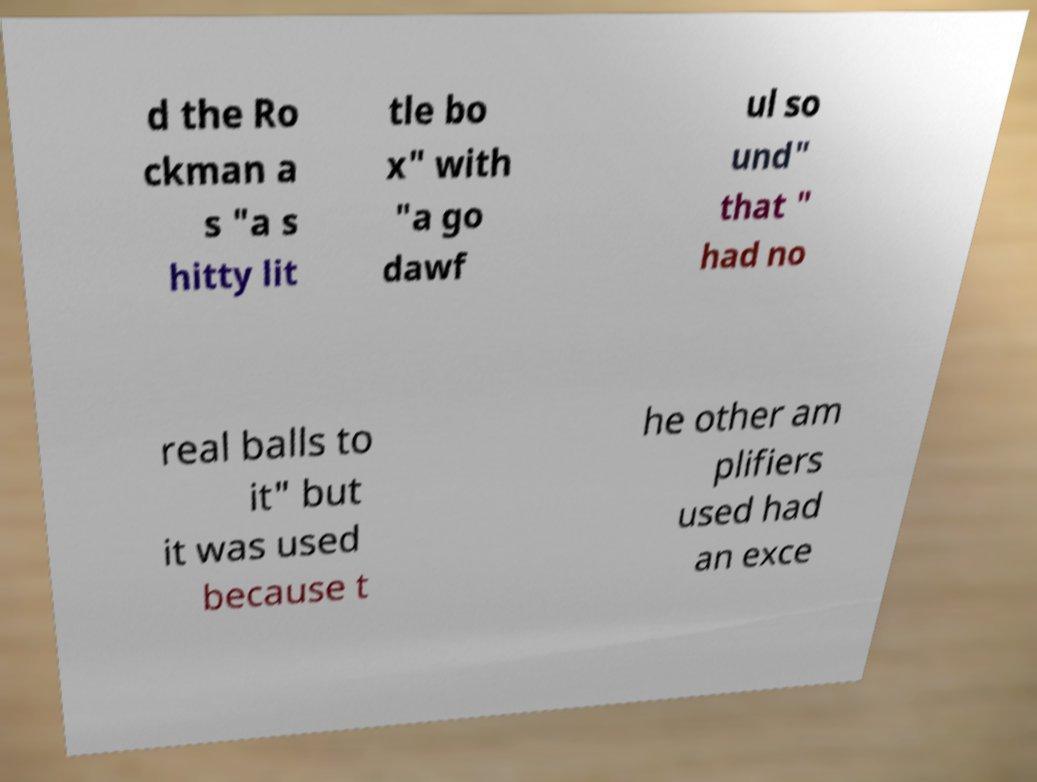Please read and relay the text visible in this image. What does it say? d the Ro ckman a s "a s hitty lit tle bo x" with "a go dawf ul so und" that " had no real balls to it" but it was used because t he other am plifiers used had an exce 